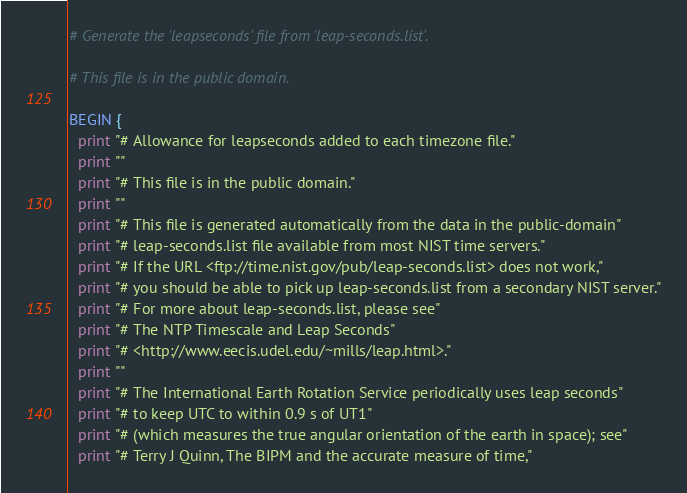<code> <loc_0><loc_0><loc_500><loc_500><_Awk_># Generate the 'leapseconds' file from 'leap-seconds.list'.

# This file is in the public domain.

BEGIN {
  print "# Allowance for leapseconds added to each timezone file."
  print ""
  print "# This file is in the public domain."
  print ""
  print "# This file is generated automatically from the data in the public-domain"
  print "# leap-seconds.list file available from most NIST time servers."
  print "# If the URL <ftp://time.nist.gov/pub/leap-seconds.list> does not work,"
  print "# you should be able to pick up leap-seconds.list from a secondary NIST server."
  print "# For more about leap-seconds.list, please see"
  print "# The NTP Timescale and Leap Seconds"
  print "# <http://www.eecis.udel.edu/~mills/leap.html>."
  print ""
  print "# The International Earth Rotation Service periodically uses leap seconds"
  print "# to keep UTC to within 0.9 s of UT1"
  print "# (which measures the true angular orientation of the earth in space); see"
  print "# Terry J Quinn, The BIPM and the accurate measure of time,"</code> 